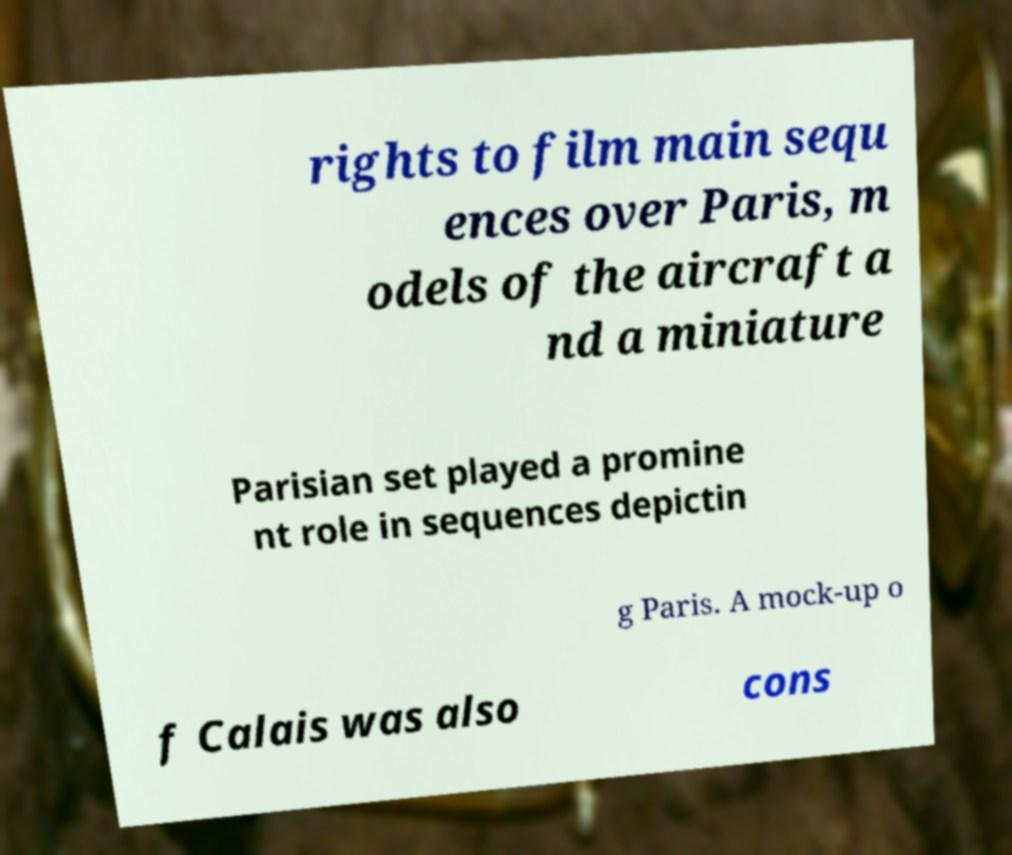Could you assist in decoding the text presented in this image and type it out clearly? rights to film main sequ ences over Paris, m odels of the aircraft a nd a miniature Parisian set played a promine nt role in sequences depictin g Paris. A mock-up o f Calais was also cons 